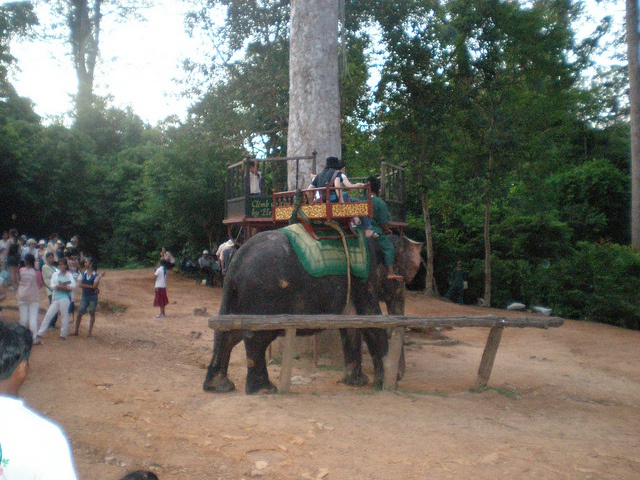Describe the objects in this image and their specific colors. I can see elephant in white, black, gray, maroon, and teal tones, people in white, black, gray, and darkgray tones, people in white, gray, and black tones, people in white, darkgray, and gray tones, and people in white, gray, black, and navy tones in this image. 